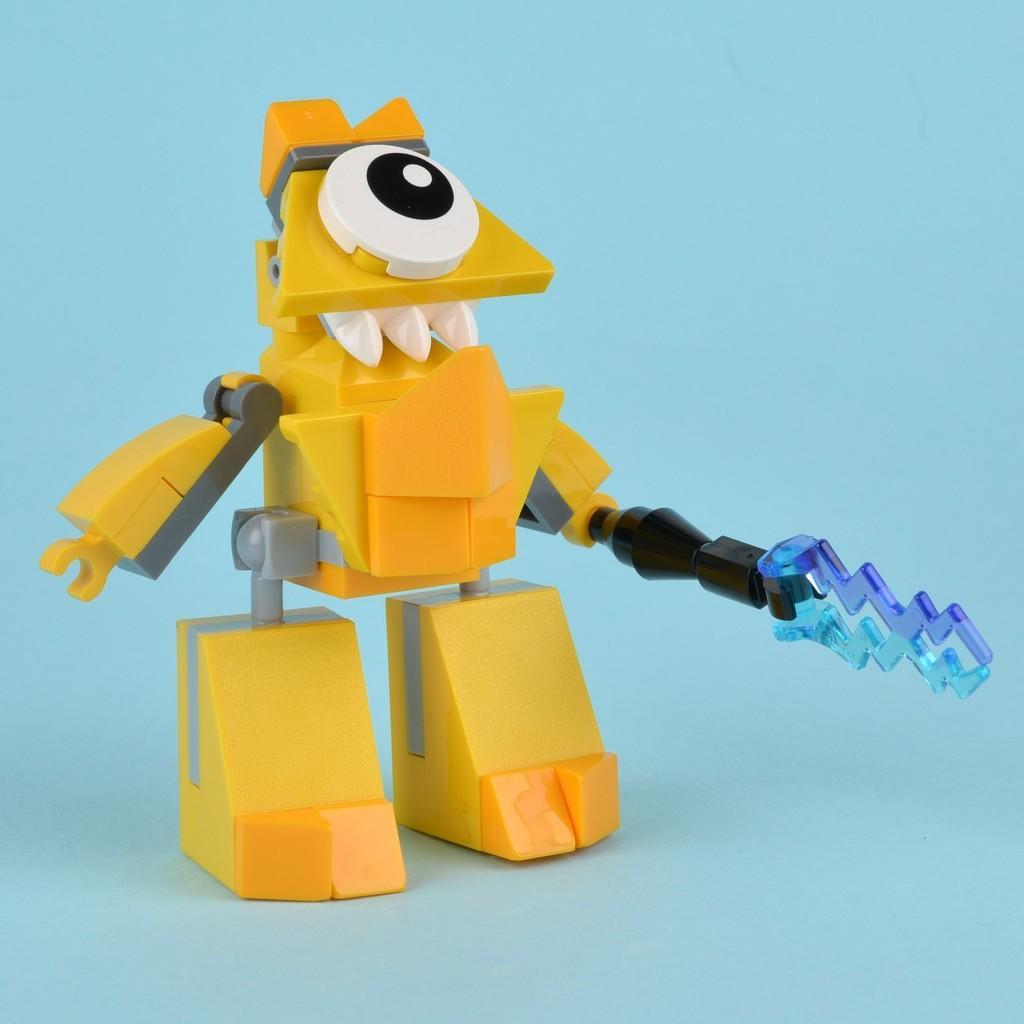In one or two sentences, can you explain what this image depicts? In the center of this picture we can see a yellow color toy holding some object and standing. The background of the image is blue in color. 